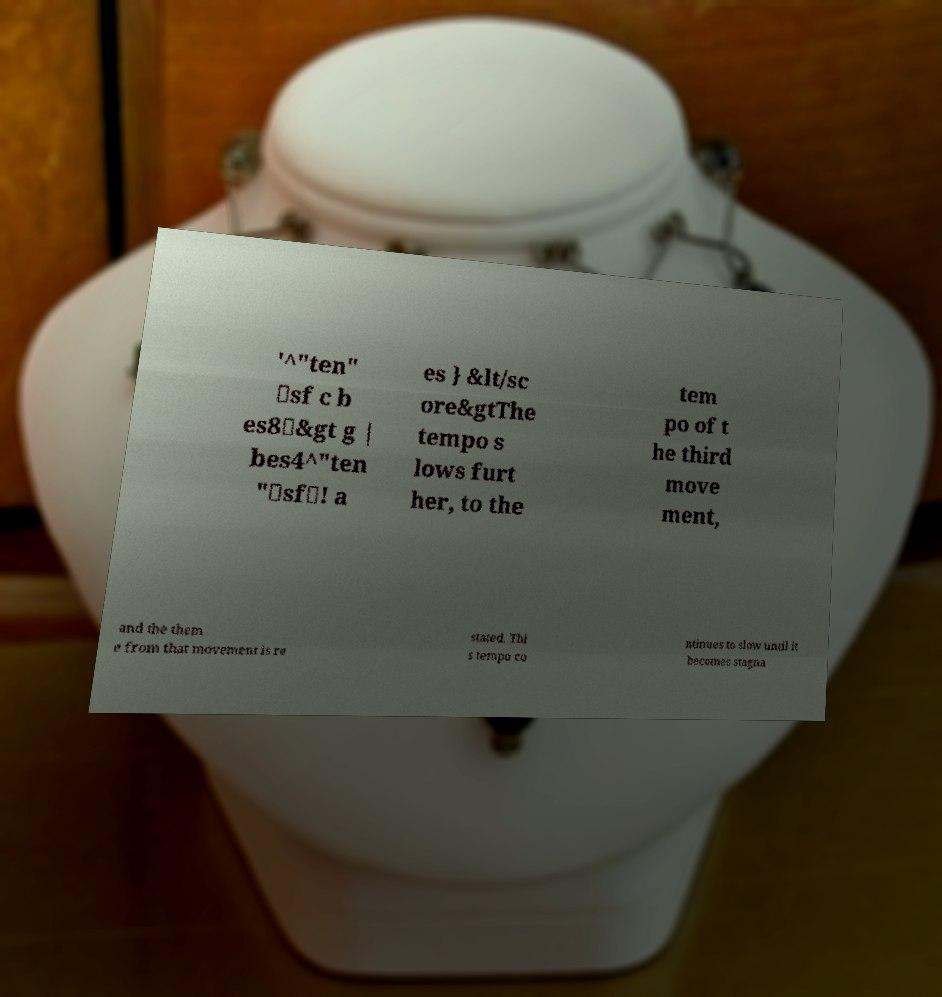For documentation purposes, I need the text within this image transcribed. Could you provide that? '^"ten" \sf c b es8\&gt g | bes4^"ten "\sf\! a es } &lt/sc ore&gtThe tempo s lows furt her, to the tem po of t he third move ment, and the them e from that movement is re stated. Thi s tempo co ntinues to slow until it becomes stagna 